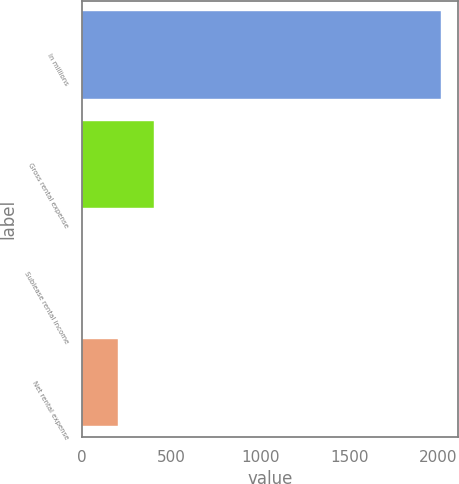Convert chart to OTSL. <chart><loc_0><loc_0><loc_500><loc_500><bar_chart><fcel>In millions<fcel>Gross rental expense<fcel>Sublease rental income<fcel>Net rental expense<nl><fcel>2013<fcel>403.32<fcel>0.9<fcel>202.11<nl></chart> 